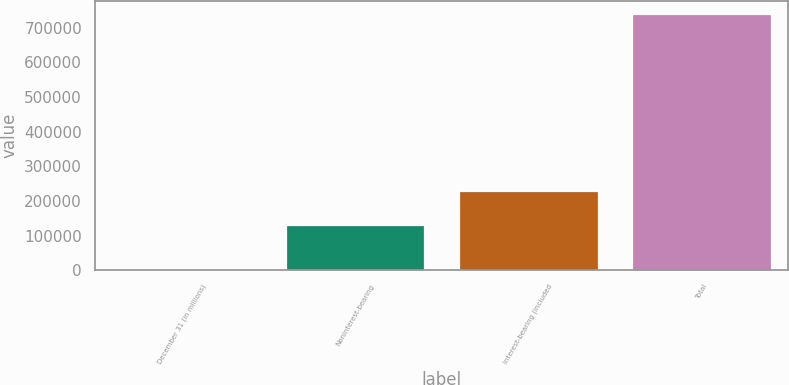<chart> <loc_0><loc_0><loc_500><loc_500><bar_chart><fcel>December 31 (in millions)<fcel>Noninterest-bearing<fcel>Interest-bearing (included<fcel>Total<nl><fcel>2007<fcel>129406<fcel>228786<fcel>740728<nl></chart> 